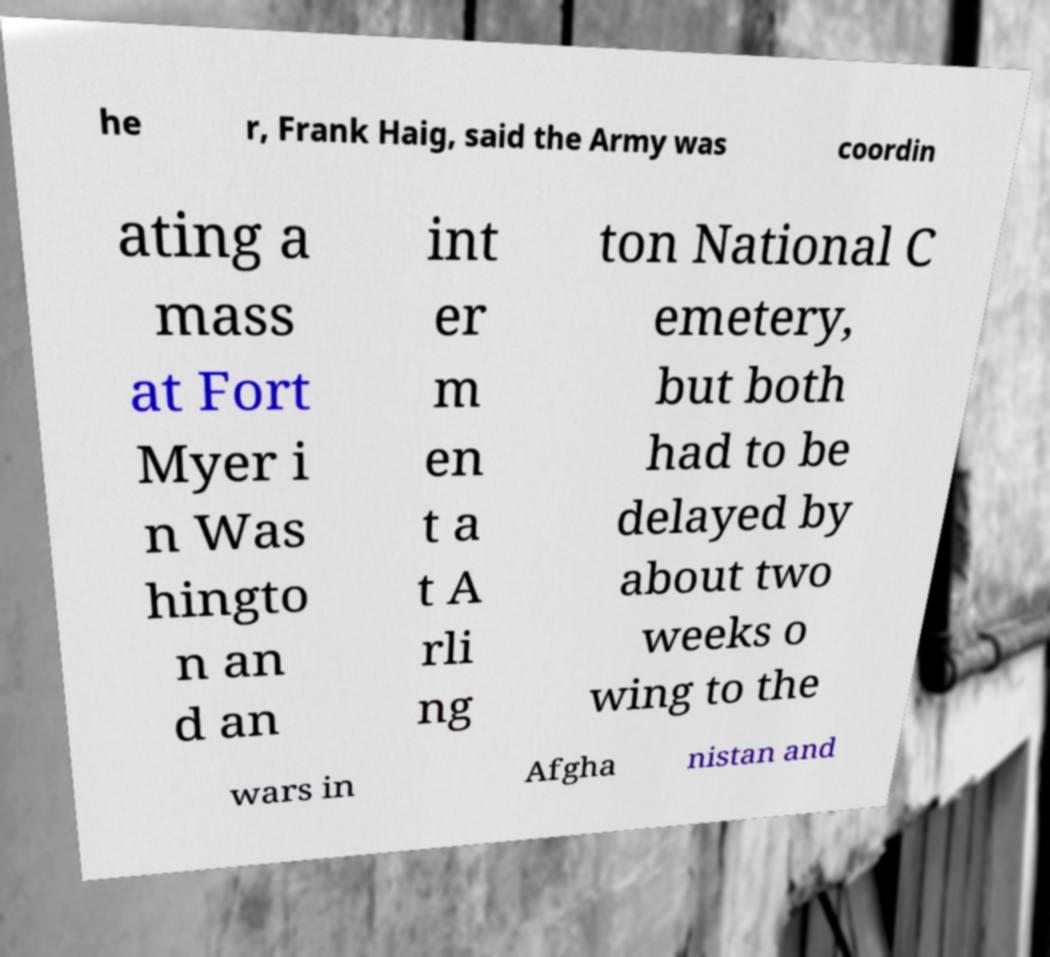What messages or text are displayed in this image? I need them in a readable, typed format. he r, Frank Haig, said the Army was coordin ating a mass at Fort Myer i n Was hingto n an d an int er m en t a t A rli ng ton National C emetery, but both had to be delayed by about two weeks o wing to the wars in Afgha nistan and 